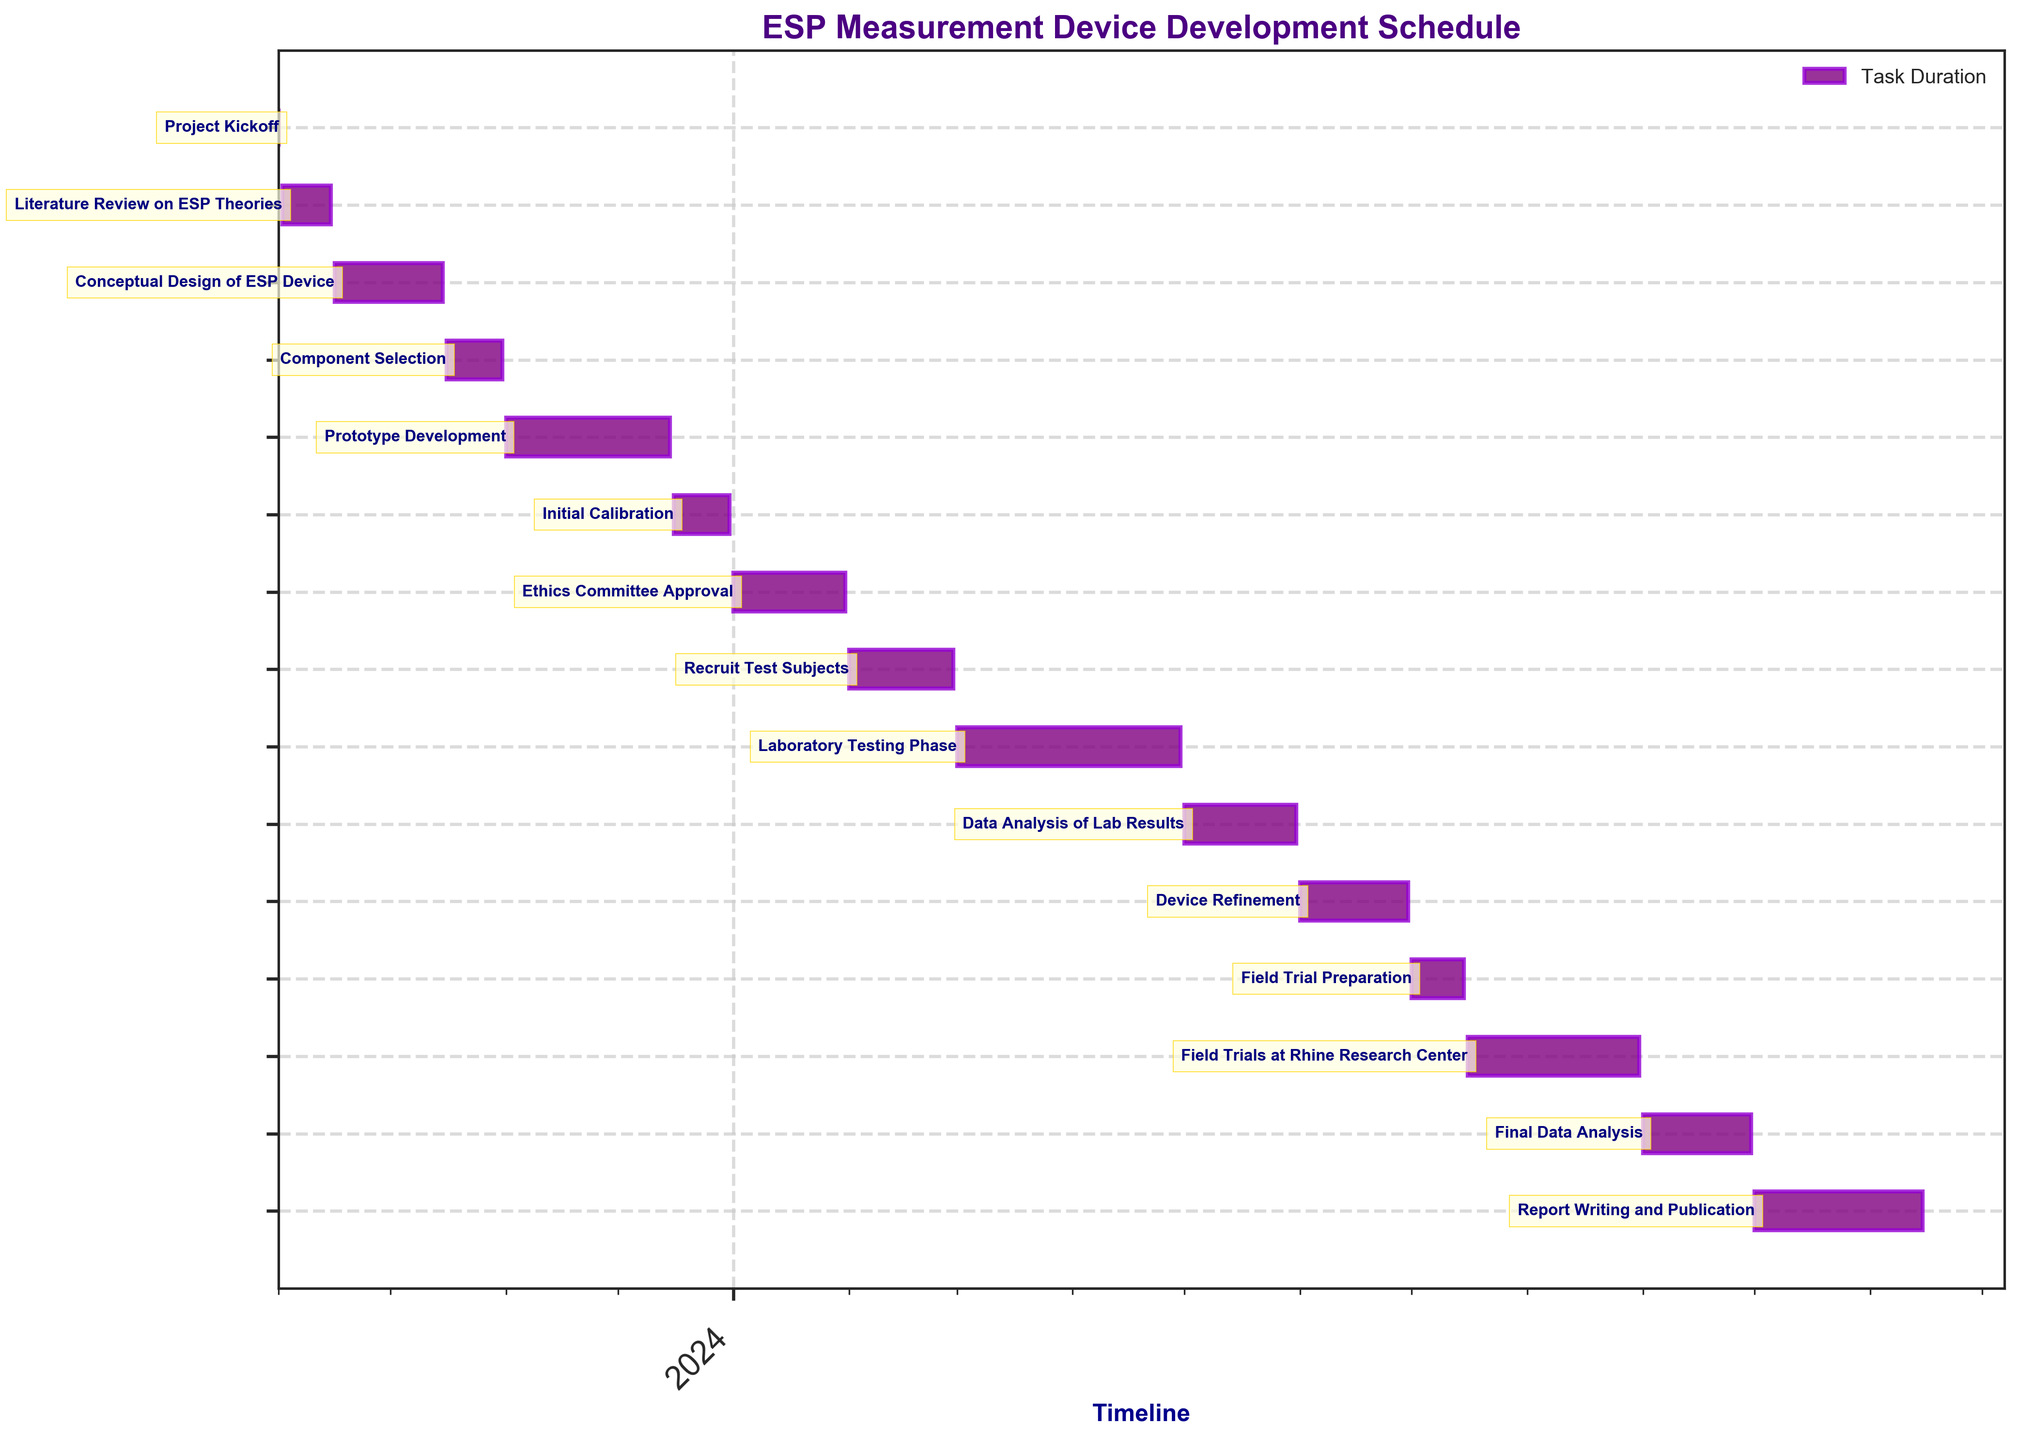What is the title of the Gantt Chart? The title of the Gantt Chart is usually the main text displayed at the top of the figure, indicating what the chart represents.
Answer: ESP Measurement Device Development Schedule On what date does the "Prototype Development" task start and end? The start and end dates for each task are shown alongside their corresponding bars. "Prototype Development" starts on 2023-11-01 and ends on 2023-12-15.
Answer: 2023-11-01 to 2023-12-15 How long is the "Literature Review on ESP Theories" task? The duration for each task is usually represented by the length of the bar. The "Literature Review on ESP Theories" task is 14 days long.
Answer: 14 days Which task has the longest duration and how long is it? By comparing the lengths of all bars, "Laboratory Testing Phase" is the longest at 61 days.
Answer: Laboratory Testing Phase, 61 days Is the "Ethics Committee Approval" completed before "Recruit Test Subjects" begins? Tasks are ordered chronologically from top to bottom, and bars begin where their start dates are. "Ethics Committee Approval" ends on 2024-01-31 and "Recruit Test Subjects" begins on 2024-02-01, so "Ethics Committee Approval" is completed before "Recruit Test Subjects."
Answer: Yes What tasks are performed simultaneously with "Field Trials at Rhine Research Center"? To find simultaneous tasks, we look for overlapping bars. Only "Field Trial Preparation" overlaps the start of "Field Trials at Rhine Research Center."
Answer: Field Trial Preparation What is the duration difference between "Conceptual Design of ESP Device" and "Prototype Development"? The "Conceptual Design of ESP Device" duration is 30 days and "Prototype Development" is 45 days. The difference is calculated as 45 - 30.
Answer: 15 days During what months is "Data Analysis of Lab Results" scheduled? By checking the start and end dates of "Data Analysis of Lab Results," which are 2024-05-01 to 2024-05-31, this task is only scheduled in May 2024.
Answer: May 2024 What is the cumulative duration of all tasks related to testing, including "Initial Calibration," "Laboratory Testing Phase," and "Field Trials at Rhine Research Center"? Sum up the durations of the tasks related to testing. "Initial Calibration" is 16 days, "Laboratory Testing Phase" is 61 days, and "Field Trials at Rhine Research Center" is 47 days. The total is 16 + 61 + 47.
Answer: 124 days Which task immediately follows "Data Analysis of Lab Results"? By looking at the sequential order of tasks and start/end dates, "Data Analysis of Lab Results" is followed by "Device Refinement," which starts right after on 2024-06-01.
Answer: Device Refinement 